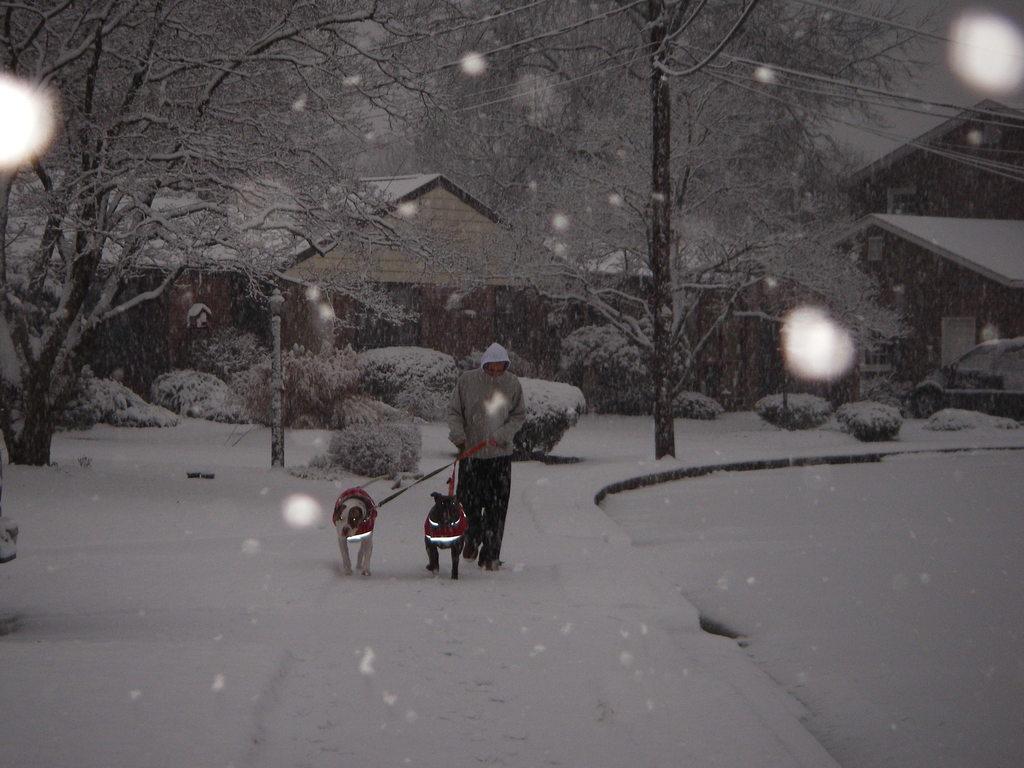In one or two sentences, can you explain what this image depicts? In this picture we can see a person and two dogs walking on snow and in the background we can see trees, houses, car. 